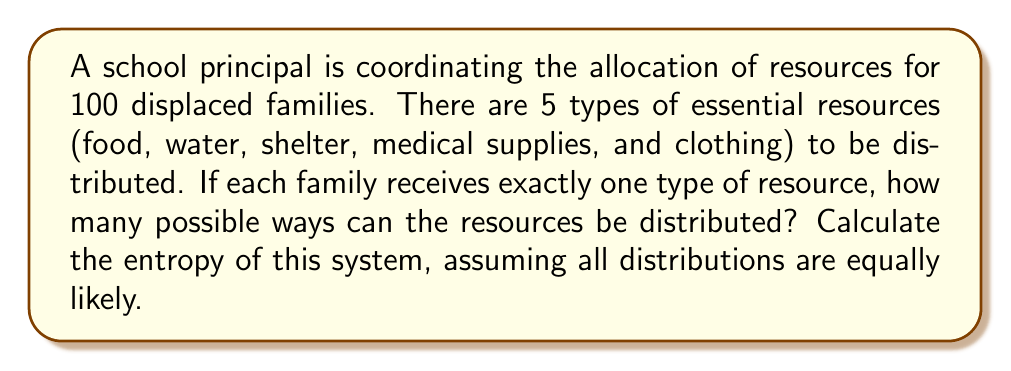Can you solve this math problem? Let's approach this step-by-step:

1) First, we need to calculate the number of possible ways to distribute the resources. This is a problem of distributing 100 indistinguishable families into 5 distinguishable resource categories.

2) This scenario follows the stars and bars combinatorics problem. The number of ways to distribute n indistinguishable objects into k distinguishable boxes is given by the formula:

   $$\binom{n+k-1}{k-1} = \binom{n+k-1}{n}$$

3) In our case, n = 100 (families) and k = 5 (resource types). So we have:

   $$\binom{100+5-1}{5-1} = \binom{104}{4}$$

4) We can calculate this:

   $$\binom{104}{4} = \frac{104!}{4!(104-4)!} = \frac{104!}{4!100!} = 4,598,126$$

5) Now that we know the number of possible states, we can calculate the entropy. In statistical mechanics, the entropy S is given by Boltzmann's formula:

   $$S = k_B \ln W$$

   Where $k_B$ is Boltzmann's constant and W is the number of microstates.

6) However, since we're dealing with a macroscopic system and not molecular states, we can use the information theory definition of entropy, which is equivalent up to a constant factor:

   $$S = \ln W$$

7) Therefore, the entropy of our system is:

   $$S = \ln(4,598,126) \approx 15.3413$$
Answer: $15.3413$ 